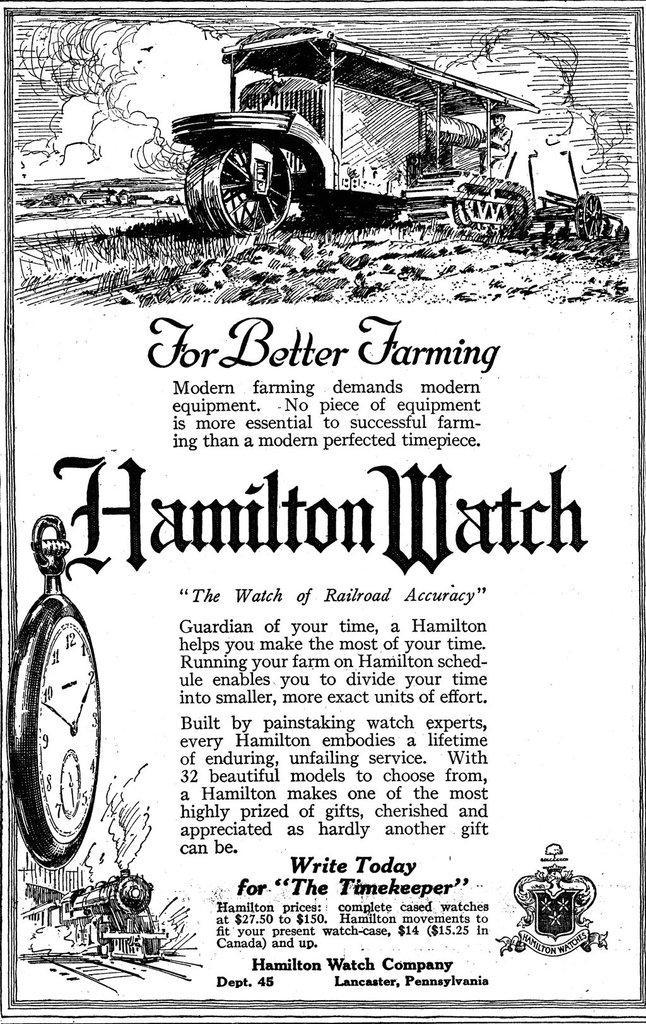Could you give a brief overview of what you see in this image? This picture shows a printed paper. We see picture of a vehicle and a train and we see a clock and we see text. 